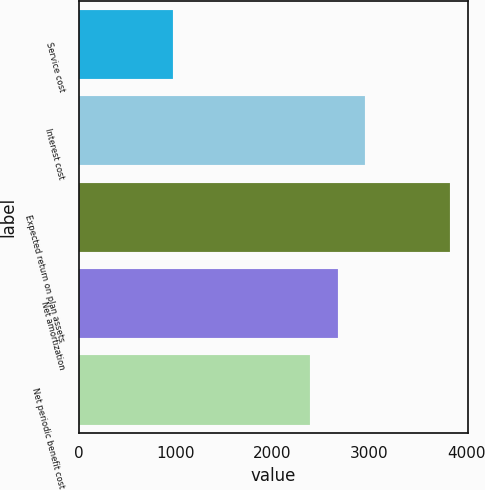<chart> <loc_0><loc_0><loc_500><loc_500><bar_chart><fcel>Service cost<fcel>Interest cost<fcel>Expected return on plan assets<fcel>Net amortization<fcel>Net periodic benefit cost<nl><fcel>976<fcel>2958.2<fcel>3832<fcel>2672.6<fcel>2387<nl></chart> 